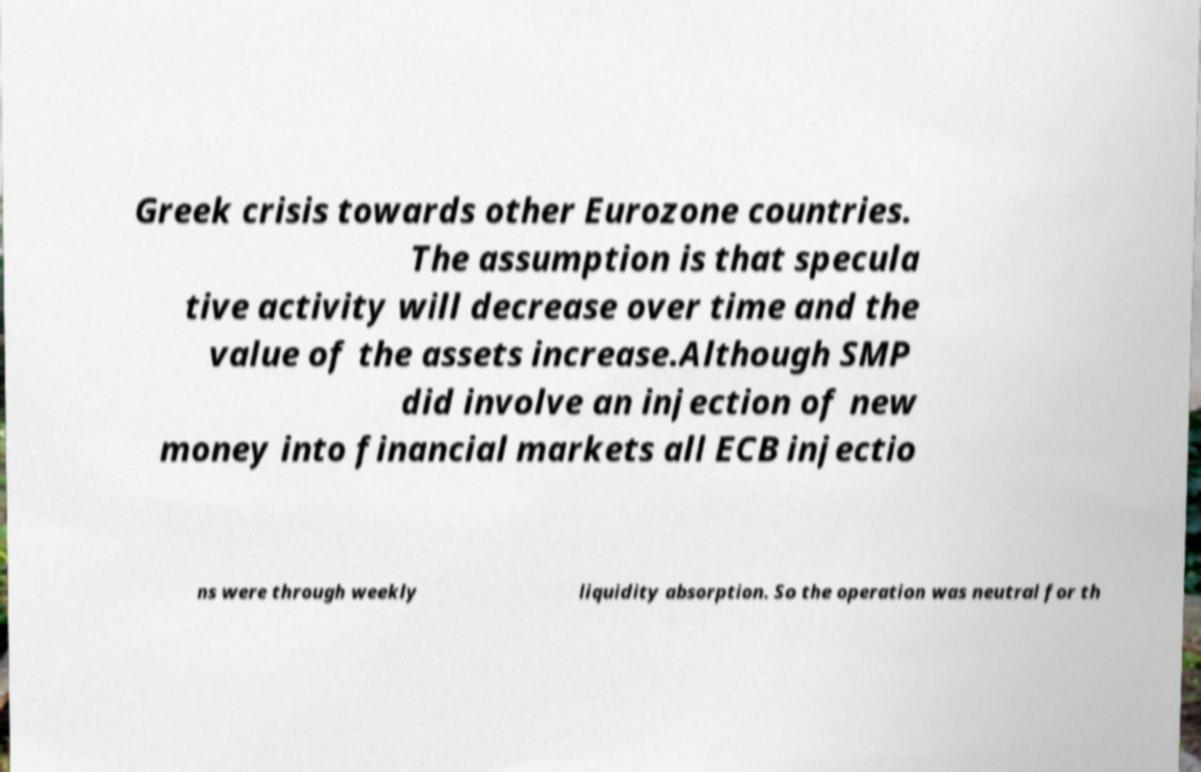Could you extract and type out the text from this image? Greek crisis towards other Eurozone countries. The assumption is that specula tive activity will decrease over time and the value of the assets increase.Although SMP did involve an injection of new money into financial markets all ECB injectio ns were through weekly liquidity absorption. So the operation was neutral for th 